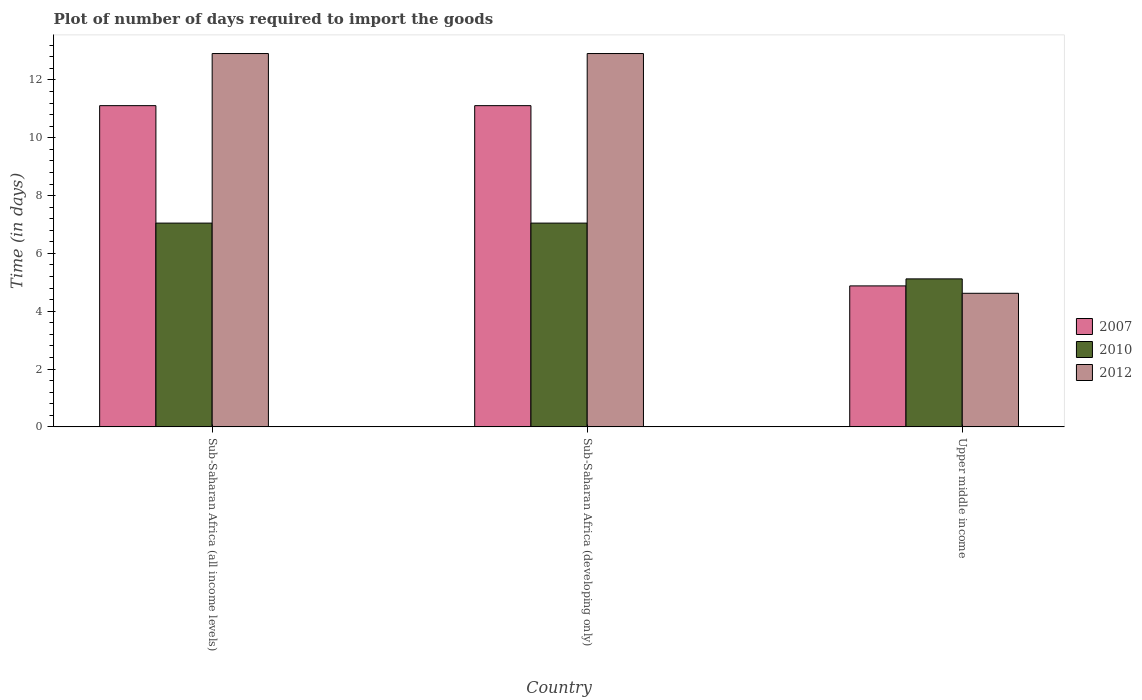How many different coloured bars are there?
Keep it short and to the point. 3. How many groups of bars are there?
Make the answer very short. 3. Are the number of bars per tick equal to the number of legend labels?
Keep it short and to the point. Yes. Are the number of bars on each tick of the X-axis equal?
Provide a succinct answer. Yes. What is the label of the 2nd group of bars from the left?
Keep it short and to the point. Sub-Saharan Africa (developing only). In how many cases, is the number of bars for a given country not equal to the number of legend labels?
Offer a very short reply. 0. What is the time required to import goods in 2012 in Upper middle income?
Provide a succinct answer. 4.62. Across all countries, what is the maximum time required to import goods in 2007?
Offer a terse response. 11.11. Across all countries, what is the minimum time required to import goods in 2010?
Keep it short and to the point. 5.12. In which country was the time required to import goods in 2007 maximum?
Ensure brevity in your answer.  Sub-Saharan Africa (all income levels). In which country was the time required to import goods in 2012 minimum?
Your response must be concise. Upper middle income. What is the total time required to import goods in 2007 in the graph?
Your answer should be very brief. 27.1. What is the difference between the time required to import goods in 2007 in Sub-Saharan Africa (developing only) and that in Upper middle income?
Your answer should be very brief. 6.23. What is the difference between the time required to import goods in 2007 in Sub-Saharan Africa (all income levels) and the time required to import goods in 2010 in Sub-Saharan Africa (developing only)?
Give a very brief answer. 4.06. What is the average time required to import goods in 2010 per country?
Your answer should be compact. 6.41. What is the difference between the time required to import goods of/in 2010 and time required to import goods of/in 2007 in Sub-Saharan Africa (developing only)?
Ensure brevity in your answer.  -4.06. What is the ratio of the time required to import goods in 2012 in Sub-Saharan Africa (all income levels) to that in Upper middle income?
Provide a short and direct response. 2.79. Is the difference between the time required to import goods in 2010 in Sub-Saharan Africa (all income levels) and Upper middle income greater than the difference between the time required to import goods in 2007 in Sub-Saharan Africa (all income levels) and Upper middle income?
Make the answer very short. No. What is the difference between the highest and the second highest time required to import goods in 2012?
Keep it short and to the point. 8.29. What is the difference between the highest and the lowest time required to import goods in 2007?
Offer a very short reply. 6.23. In how many countries, is the time required to import goods in 2012 greater than the average time required to import goods in 2012 taken over all countries?
Give a very brief answer. 2. What does the 2nd bar from the right in Upper middle income represents?
Offer a terse response. 2010. Is it the case that in every country, the sum of the time required to import goods in 2010 and time required to import goods in 2012 is greater than the time required to import goods in 2007?
Your answer should be compact. Yes. Does the graph contain any zero values?
Give a very brief answer. No. What is the title of the graph?
Your answer should be very brief. Plot of number of days required to import the goods. What is the label or title of the X-axis?
Your response must be concise. Country. What is the label or title of the Y-axis?
Give a very brief answer. Time (in days). What is the Time (in days) of 2007 in Sub-Saharan Africa (all income levels)?
Give a very brief answer. 11.11. What is the Time (in days) of 2010 in Sub-Saharan Africa (all income levels)?
Make the answer very short. 7.05. What is the Time (in days) of 2012 in Sub-Saharan Africa (all income levels)?
Ensure brevity in your answer.  12.91. What is the Time (in days) in 2007 in Sub-Saharan Africa (developing only)?
Make the answer very short. 11.11. What is the Time (in days) in 2010 in Sub-Saharan Africa (developing only)?
Provide a short and direct response. 7.05. What is the Time (in days) in 2012 in Sub-Saharan Africa (developing only)?
Provide a succinct answer. 12.91. What is the Time (in days) in 2007 in Upper middle income?
Ensure brevity in your answer.  4.88. What is the Time (in days) in 2010 in Upper middle income?
Your answer should be compact. 5.12. What is the Time (in days) in 2012 in Upper middle income?
Ensure brevity in your answer.  4.62. Across all countries, what is the maximum Time (in days) in 2007?
Make the answer very short. 11.11. Across all countries, what is the maximum Time (in days) in 2010?
Offer a very short reply. 7.05. Across all countries, what is the maximum Time (in days) in 2012?
Your response must be concise. 12.91. Across all countries, what is the minimum Time (in days) in 2007?
Provide a short and direct response. 4.88. Across all countries, what is the minimum Time (in days) in 2010?
Offer a very short reply. 5.12. Across all countries, what is the minimum Time (in days) in 2012?
Give a very brief answer. 4.62. What is the total Time (in days) of 2007 in the graph?
Offer a very short reply. 27.1. What is the total Time (in days) of 2010 in the graph?
Offer a very short reply. 19.22. What is the total Time (in days) of 2012 in the graph?
Offer a very short reply. 30.45. What is the difference between the Time (in days) in 2007 in Sub-Saharan Africa (all income levels) and that in Sub-Saharan Africa (developing only)?
Provide a succinct answer. 0. What is the difference between the Time (in days) of 2012 in Sub-Saharan Africa (all income levels) and that in Sub-Saharan Africa (developing only)?
Ensure brevity in your answer.  0. What is the difference between the Time (in days) of 2007 in Sub-Saharan Africa (all income levels) and that in Upper middle income?
Provide a short and direct response. 6.23. What is the difference between the Time (in days) of 2010 in Sub-Saharan Africa (all income levels) and that in Upper middle income?
Your answer should be very brief. 1.93. What is the difference between the Time (in days) in 2012 in Sub-Saharan Africa (all income levels) and that in Upper middle income?
Make the answer very short. 8.29. What is the difference between the Time (in days) of 2007 in Sub-Saharan Africa (developing only) and that in Upper middle income?
Your answer should be compact. 6.23. What is the difference between the Time (in days) of 2010 in Sub-Saharan Africa (developing only) and that in Upper middle income?
Keep it short and to the point. 1.93. What is the difference between the Time (in days) of 2012 in Sub-Saharan Africa (developing only) and that in Upper middle income?
Keep it short and to the point. 8.29. What is the difference between the Time (in days) of 2007 in Sub-Saharan Africa (all income levels) and the Time (in days) of 2010 in Sub-Saharan Africa (developing only)?
Offer a terse response. 4.06. What is the difference between the Time (in days) in 2007 in Sub-Saharan Africa (all income levels) and the Time (in days) in 2012 in Sub-Saharan Africa (developing only)?
Your answer should be very brief. -1.8. What is the difference between the Time (in days) in 2010 in Sub-Saharan Africa (all income levels) and the Time (in days) in 2012 in Sub-Saharan Africa (developing only)?
Your answer should be very brief. -5.86. What is the difference between the Time (in days) in 2007 in Sub-Saharan Africa (all income levels) and the Time (in days) in 2010 in Upper middle income?
Offer a terse response. 5.99. What is the difference between the Time (in days) of 2007 in Sub-Saharan Africa (all income levels) and the Time (in days) of 2012 in Upper middle income?
Provide a short and direct response. 6.49. What is the difference between the Time (in days) of 2010 in Sub-Saharan Africa (all income levels) and the Time (in days) of 2012 in Upper middle income?
Offer a very short reply. 2.43. What is the difference between the Time (in days) in 2007 in Sub-Saharan Africa (developing only) and the Time (in days) in 2010 in Upper middle income?
Give a very brief answer. 5.99. What is the difference between the Time (in days) of 2007 in Sub-Saharan Africa (developing only) and the Time (in days) of 2012 in Upper middle income?
Provide a succinct answer. 6.49. What is the difference between the Time (in days) of 2010 in Sub-Saharan Africa (developing only) and the Time (in days) of 2012 in Upper middle income?
Offer a terse response. 2.43. What is the average Time (in days) of 2007 per country?
Provide a succinct answer. 9.03. What is the average Time (in days) of 2010 per country?
Provide a succinct answer. 6.41. What is the average Time (in days) in 2012 per country?
Provide a short and direct response. 10.15. What is the difference between the Time (in days) in 2007 and Time (in days) in 2010 in Sub-Saharan Africa (all income levels)?
Offer a terse response. 4.06. What is the difference between the Time (in days) of 2007 and Time (in days) of 2012 in Sub-Saharan Africa (all income levels)?
Make the answer very short. -1.8. What is the difference between the Time (in days) in 2010 and Time (in days) in 2012 in Sub-Saharan Africa (all income levels)?
Give a very brief answer. -5.86. What is the difference between the Time (in days) in 2007 and Time (in days) in 2010 in Sub-Saharan Africa (developing only)?
Provide a succinct answer. 4.06. What is the difference between the Time (in days) in 2007 and Time (in days) in 2012 in Sub-Saharan Africa (developing only)?
Your answer should be compact. -1.8. What is the difference between the Time (in days) in 2010 and Time (in days) in 2012 in Sub-Saharan Africa (developing only)?
Make the answer very short. -5.86. What is the difference between the Time (in days) in 2007 and Time (in days) in 2010 in Upper middle income?
Make the answer very short. -0.24. What is the difference between the Time (in days) of 2007 and Time (in days) of 2012 in Upper middle income?
Your answer should be compact. 0.26. What is the difference between the Time (in days) in 2010 and Time (in days) in 2012 in Upper middle income?
Make the answer very short. 0.5. What is the ratio of the Time (in days) of 2007 in Sub-Saharan Africa (all income levels) to that in Upper middle income?
Ensure brevity in your answer.  2.28. What is the ratio of the Time (in days) of 2010 in Sub-Saharan Africa (all income levels) to that in Upper middle income?
Your response must be concise. 1.38. What is the ratio of the Time (in days) of 2012 in Sub-Saharan Africa (all income levels) to that in Upper middle income?
Provide a succinct answer. 2.79. What is the ratio of the Time (in days) in 2007 in Sub-Saharan Africa (developing only) to that in Upper middle income?
Provide a short and direct response. 2.28. What is the ratio of the Time (in days) of 2010 in Sub-Saharan Africa (developing only) to that in Upper middle income?
Make the answer very short. 1.38. What is the ratio of the Time (in days) of 2012 in Sub-Saharan Africa (developing only) to that in Upper middle income?
Offer a terse response. 2.79. What is the difference between the highest and the second highest Time (in days) of 2010?
Ensure brevity in your answer.  0. What is the difference between the highest and the second highest Time (in days) in 2012?
Give a very brief answer. 0. What is the difference between the highest and the lowest Time (in days) of 2007?
Your response must be concise. 6.23. What is the difference between the highest and the lowest Time (in days) in 2010?
Offer a terse response. 1.93. What is the difference between the highest and the lowest Time (in days) in 2012?
Offer a very short reply. 8.29. 